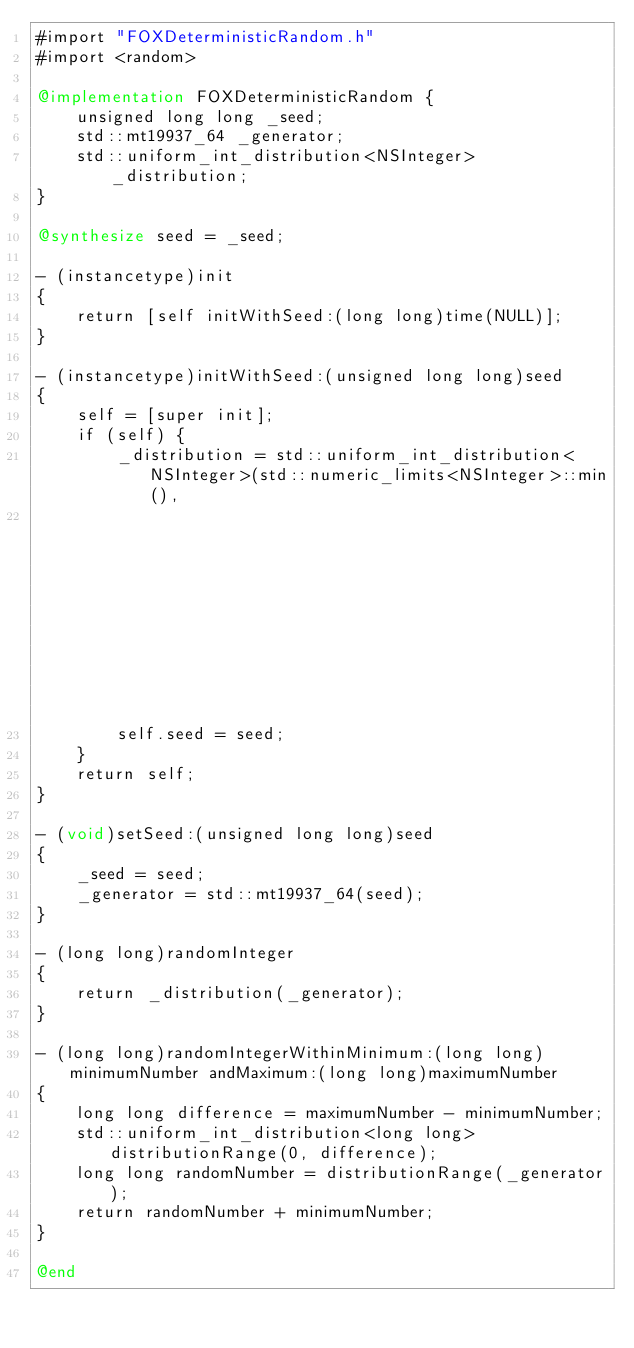Convert code to text. <code><loc_0><loc_0><loc_500><loc_500><_ObjectiveC_>#import "FOXDeterministicRandom.h"
#import <random>

@implementation FOXDeterministicRandom {
    unsigned long long _seed;
    std::mt19937_64 _generator;
    std::uniform_int_distribution<NSInteger> _distribution;
}

@synthesize seed = _seed;

- (instancetype)init
{
    return [self initWithSeed:(long long)time(NULL)];
}

- (instancetype)initWithSeed:(unsigned long long)seed
{
    self = [super init];
    if (self) {
        _distribution = std::uniform_int_distribution<NSInteger>(std::numeric_limits<NSInteger>::min(),
                                                                 std::numeric_limits<NSInteger>::max());
        self.seed = seed;
    }
    return self;
}

- (void)setSeed:(unsigned long long)seed
{
    _seed = seed;
    _generator = std::mt19937_64(seed);
}

- (long long)randomInteger
{
    return _distribution(_generator);
}

- (long long)randomIntegerWithinMinimum:(long long)minimumNumber andMaximum:(long long)maximumNumber
{
    long long difference = maximumNumber - minimumNumber;
    std::uniform_int_distribution<long long> distributionRange(0, difference);
    long long randomNumber = distributionRange(_generator);
    return randomNumber + minimumNumber;
}

@end
</code> 